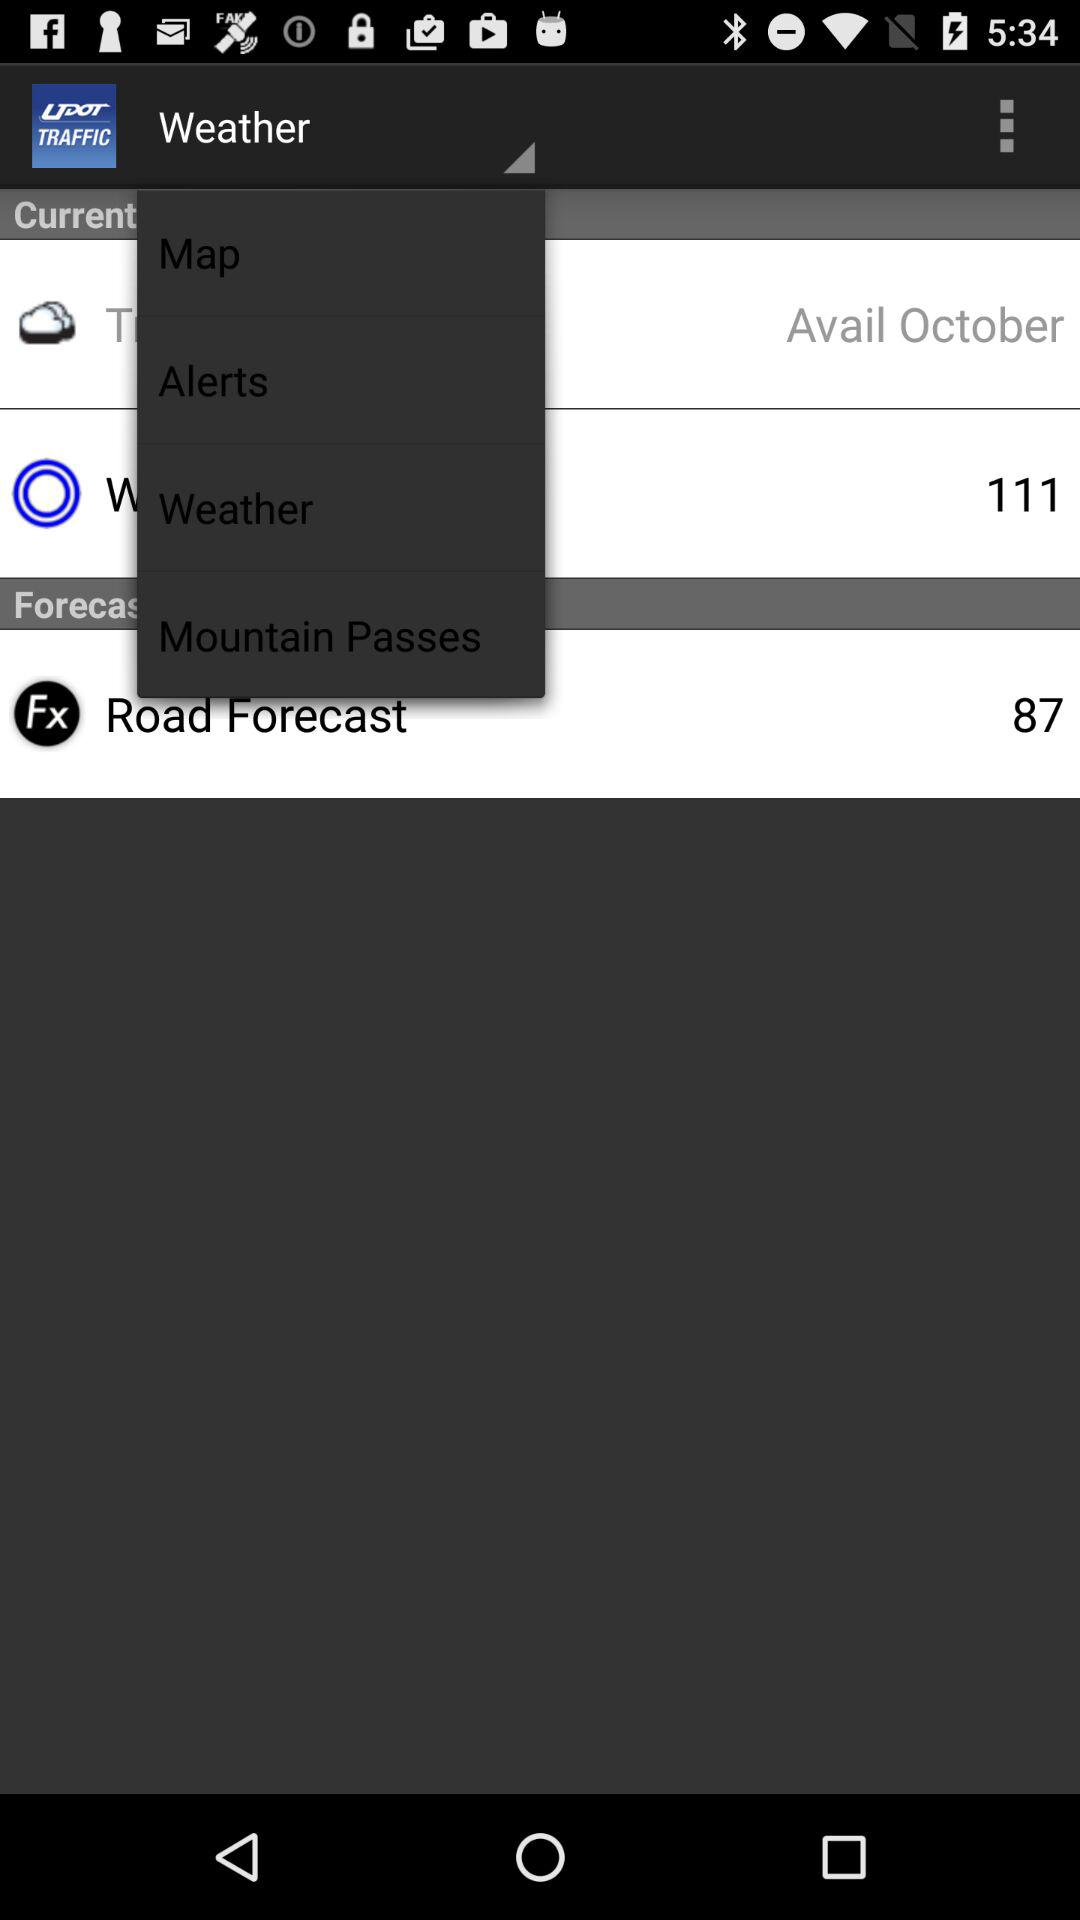What is the number in "Road Forecast"? The number in "Road Forecast" is 87. 